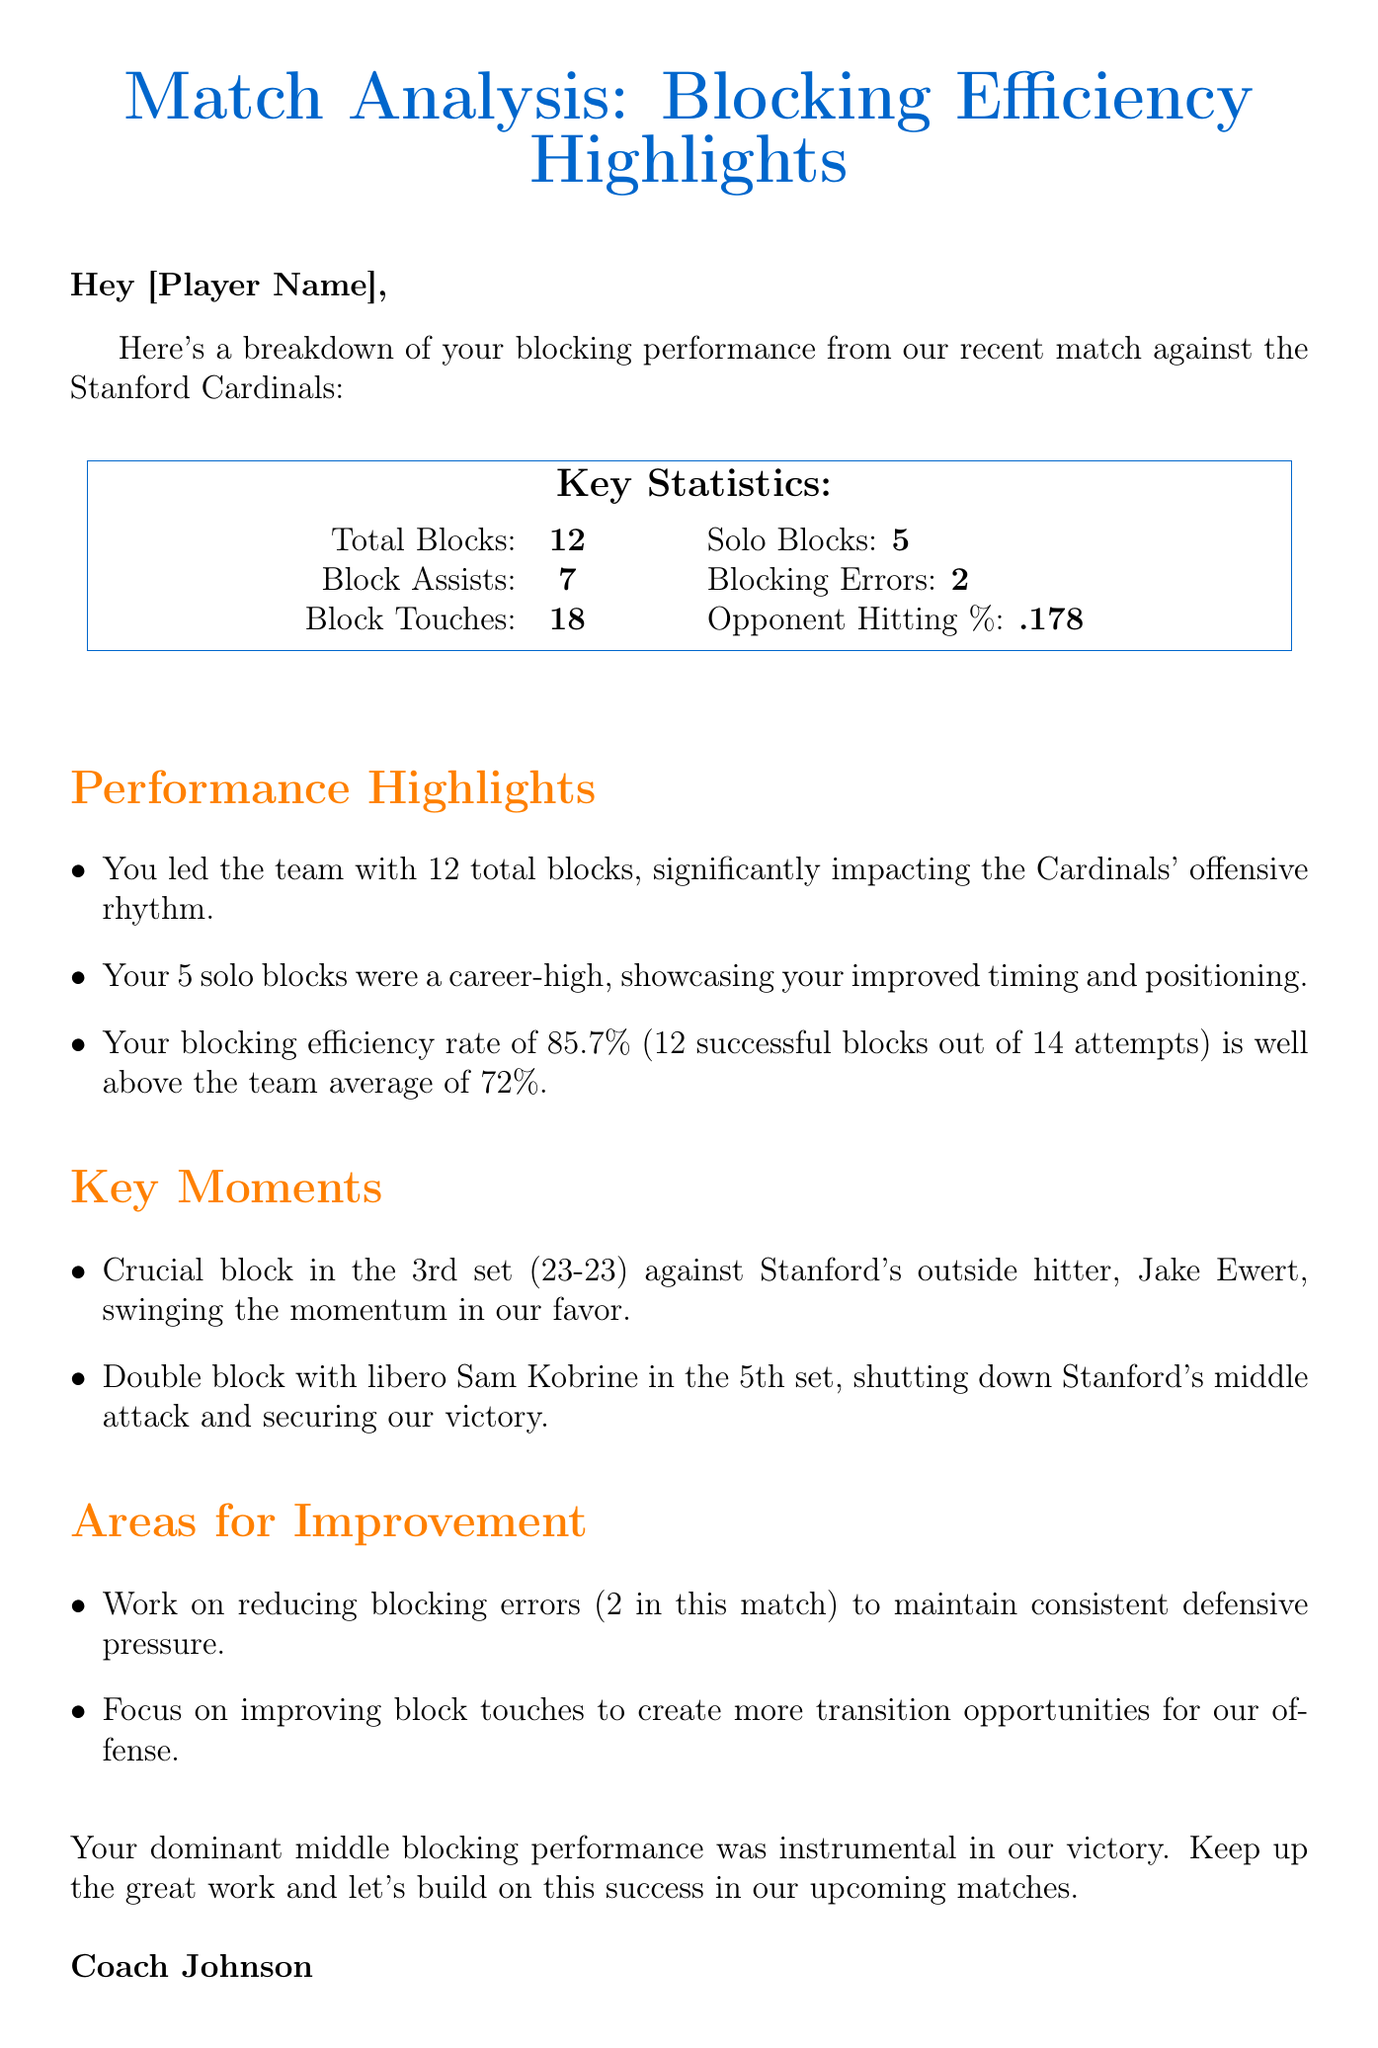what is the subject of the email? The subject is stated at the beginning of the document, titled "Match Analysis: Blocking Efficiency Highlights."
Answer: Match Analysis: Blocking Efficiency Highlights how many total blocks did you achieve? The total blocks are clearly summarized in the key statistics section of the document, which states "Total Blocks: 12."
Answer: 12 what was your blocking efficiency rate? The document specifically mentions your blocking efficiency rate as "85.7% (12 successful blocks out of 14 attempts)."
Answer: 85.7% who did you have a crucial block against in the 3rd set? The document notes the key moments, highlighting the block against "Stanford's outside hitter, Jake Ewert."
Answer: Jake Ewert how many solo blocks did you make in this match? The key statistics indicate the number of solo blocks as "Solo Blocks: 5."
Answer: 5 what is one area for improvement mentioned in the document? The document lists areas for improvement, specifically mentioning "Work on reducing blocking errors (2 in this match)."
Answer: Reducing blocking errors how many block touches did you have? The total block touches are indicated in the key statistics as "Block Touches: 18."
Answer: 18 who is the author of the email? The signature at the end of the document specifies the author's name as "Coach Johnson."
Answer: Coach Johnson what was the opponent's hitting percentage? The document provides this information under the key statistics section, stating "Opponent Hitting %: .178."
Answer: .178 